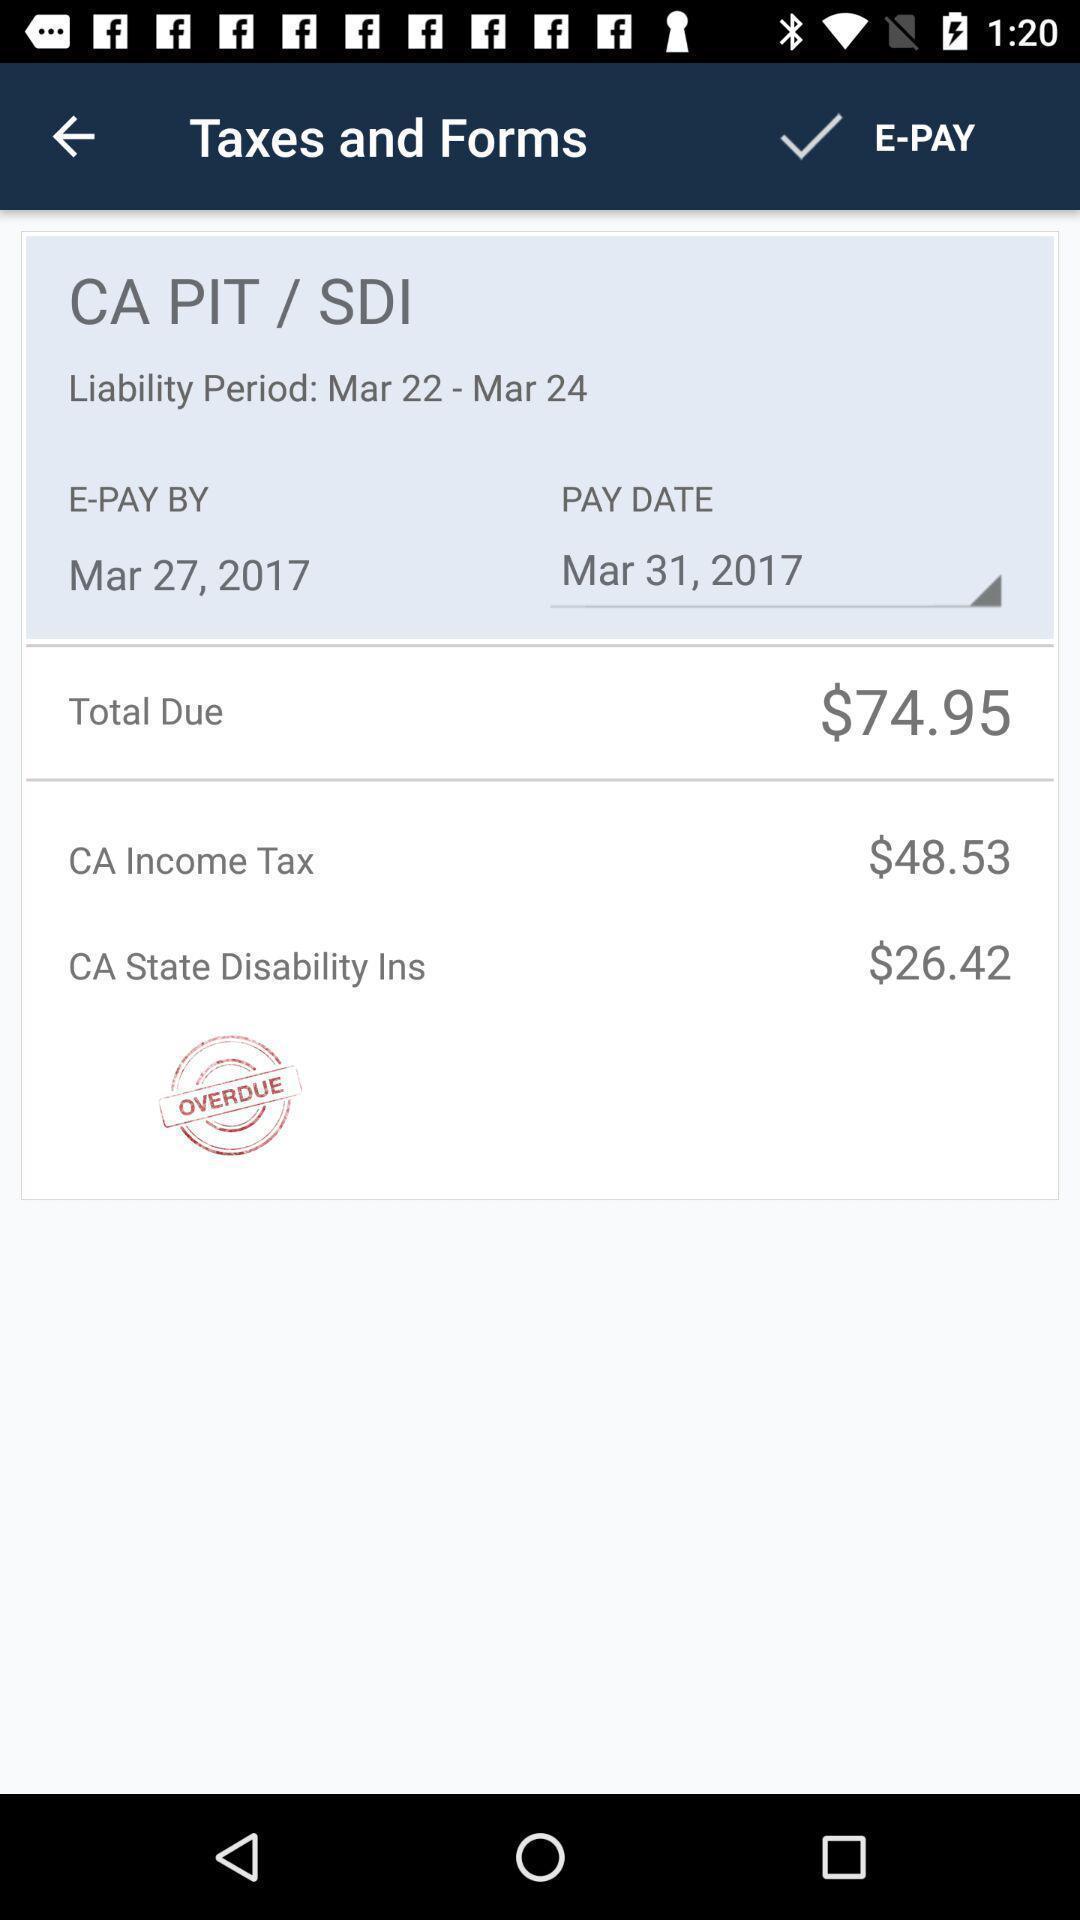Explain what's happening in this screen capture. Screen showing taxes and forms. 